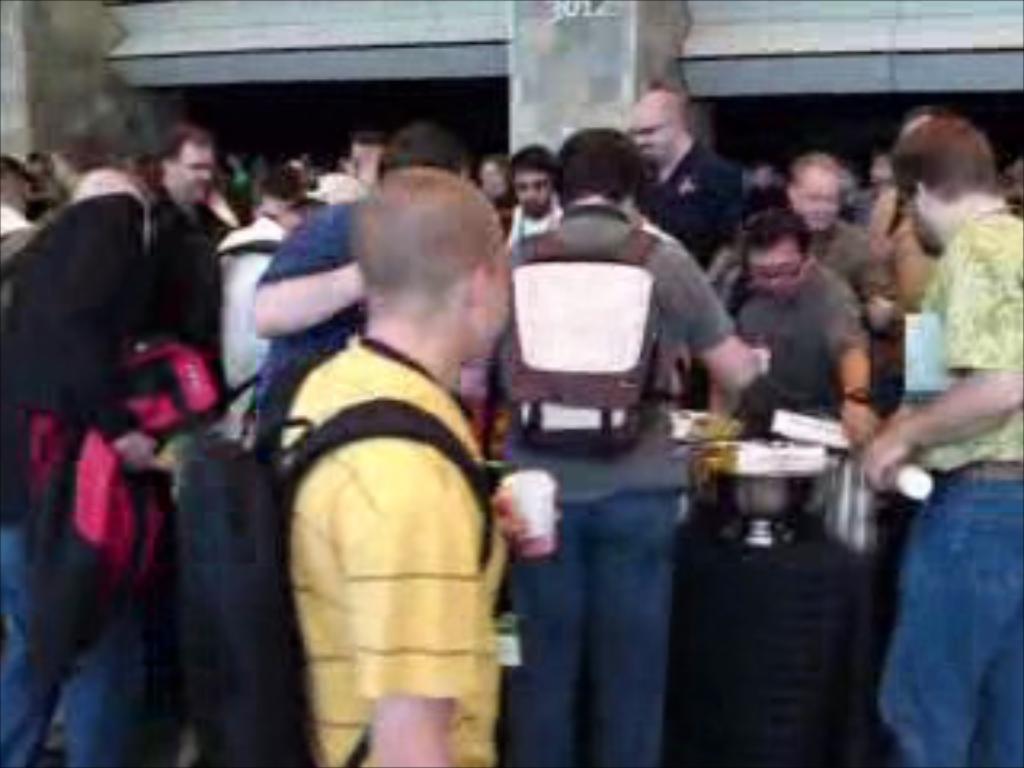Please provide a concise description of this image. There are few persons standing around the table which has few objects placed on it. 